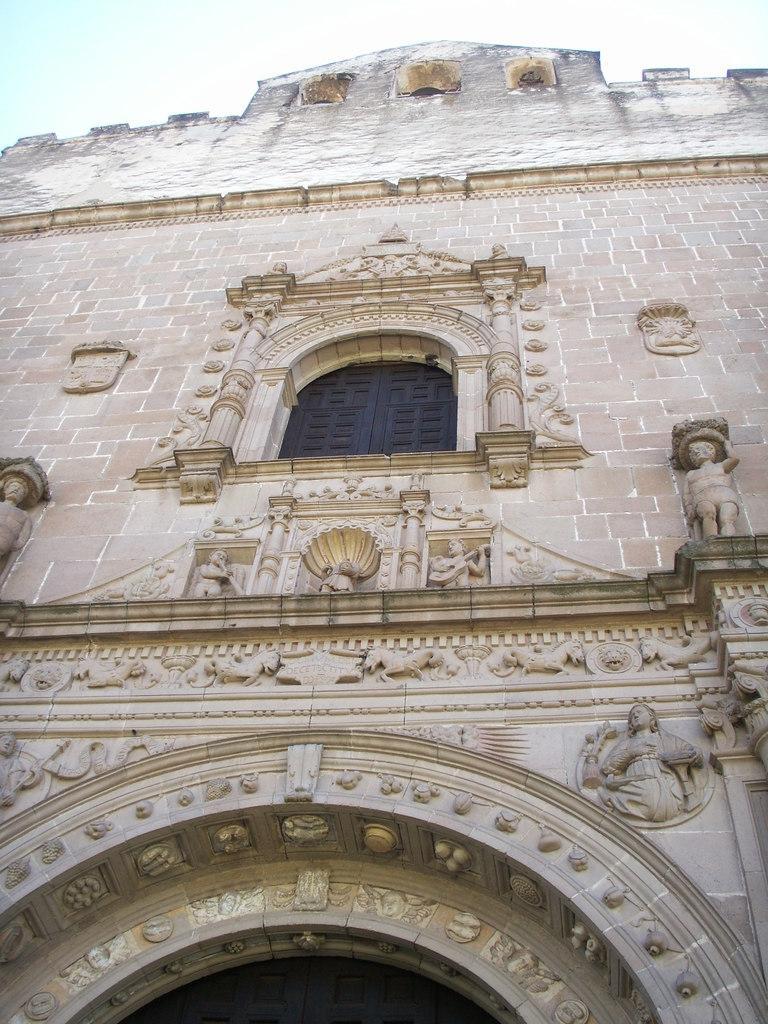How would you summarize this image in a sentence or two? In this image I can see the building. There is a window to the building. I can also see the statues to the side. In the background there is a sky. 